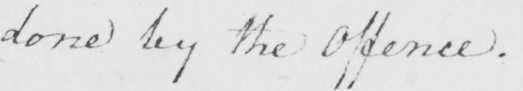What is written in this line of handwriting? done by the Offence . 